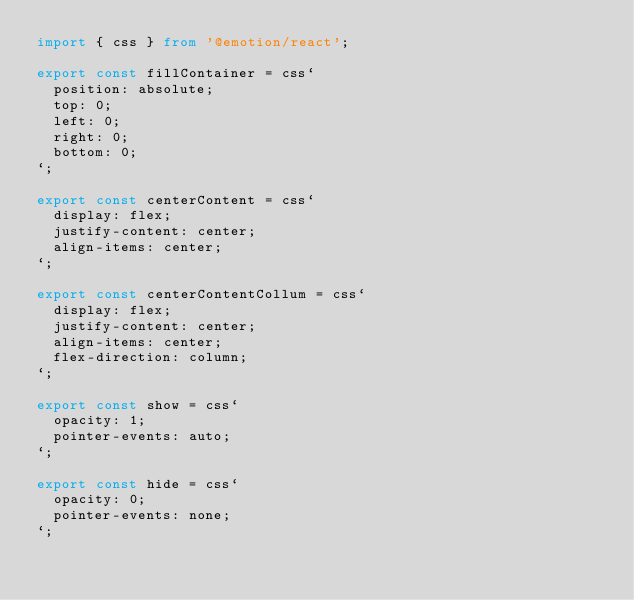Convert code to text. <code><loc_0><loc_0><loc_500><loc_500><_TypeScript_>import { css } from '@emotion/react';

export const fillContainer = css`
  position: absolute;
  top: 0;
  left: 0;
  right: 0;
  bottom: 0;
`;

export const centerContent = css`
  display: flex;
  justify-content: center;
  align-items: center;
`;

export const centerContentCollum = css`
  display: flex;
  justify-content: center;
  align-items: center;
  flex-direction: column;
`;

export const show = css`
  opacity: 1;
  pointer-events: auto;
`;

export const hide = css`
  opacity: 0;
  pointer-events: none;
`;
</code> 